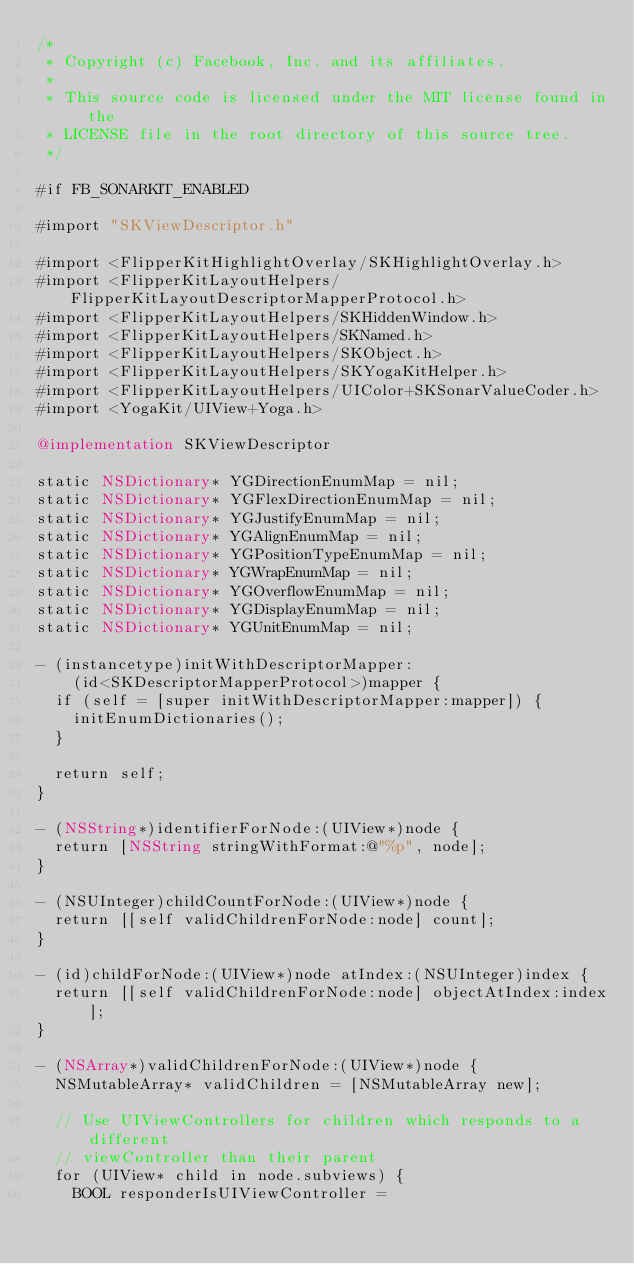Convert code to text. <code><loc_0><loc_0><loc_500><loc_500><_ObjectiveC_>/*
 * Copyright (c) Facebook, Inc. and its affiliates.
 *
 * This source code is licensed under the MIT license found in the
 * LICENSE file in the root directory of this source tree.
 */

#if FB_SONARKIT_ENABLED

#import "SKViewDescriptor.h"

#import <FlipperKitHighlightOverlay/SKHighlightOverlay.h>
#import <FlipperKitLayoutHelpers/FlipperKitLayoutDescriptorMapperProtocol.h>
#import <FlipperKitLayoutHelpers/SKHiddenWindow.h>
#import <FlipperKitLayoutHelpers/SKNamed.h>
#import <FlipperKitLayoutHelpers/SKObject.h>
#import <FlipperKitLayoutHelpers/SKYogaKitHelper.h>
#import <FlipperKitLayoutHelpers/UIColor+SKSonarValueCoder.h>
#import <YogaKit/UIView+Yoga.h>

@implementation SKViewDescriptor

static NSDictionary* YGDirectionEnumMap = nil;
static NSDictionary* YGFlexDirectionEnumMap = nil;
static NSDictionary* YGJustifyEnumMap = nil;
static NSDictionary* YGAlignEnumMap = nil;
static NSDictionary* YGPositionTypeEnumMap = nil;
static NSDictionary* YGWrapEnumMap = nil;
static NSDictionary* YGOverflowEnumMap = nil;
static NSDictionary* YGDisplayEnumMap = nil;
static NSDictionary* YGUnitEnumMap = nil;

- (instancetype)initWithDescriptorMapper:
    (id<SKDescriptorMapperProtocol>)mapper {
  if (self = [super initWithDescriptorMapper:mapper]) {
    initEnumDictionaries();
  }

  return self;
}

- (NSString*)identifierForNode:(UIView*)node {
  return [NSString stringWithFormat:@"%p", node];
}

- (NSUInteger)childCountForNode:(UIView*)node {
  return [[self validChildrenForNode:node] count];
}

- (id)childForNode:(UIView*)node atIndex:(NSUInteger)index {
  return [[self validChildrenForNode:node] objectAtIndex:index];
}

- (NSArray*)validChildrenForNode:(UIView*)node {
  NSMutableArray* validChildren = [NSMutableArray new];

  // Use UIViewControllers for children which responds to a different
  // viewController than their parent
  for (UIView* child in node.subviews) {
    BOOL responderIsUIViewController =</code> 